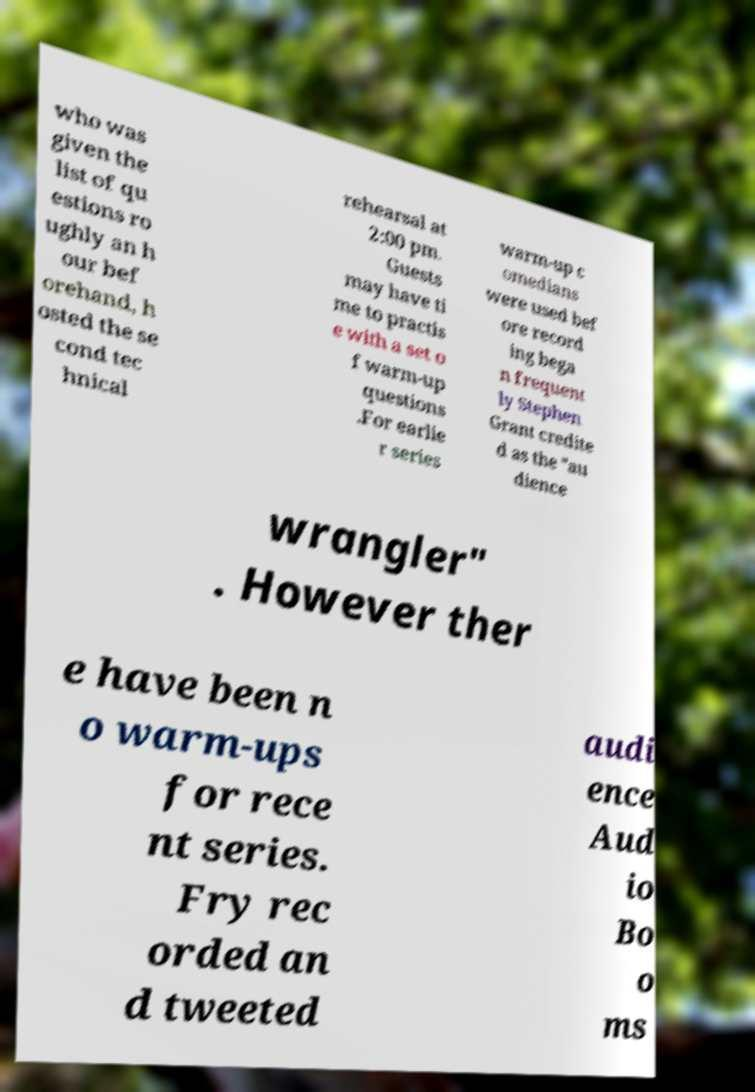Please identify and transcribe the text found in this image. who was given the list of qu estions ro ughly an h our bef orehand, h osted the se cond tec hnical rehearsal at 2:00 pm. Guests may have ti me to practis e with a set o f warm-up questions .For earlie r series warm-up c omedians were used bef ore record ing bega n frequent ly Stephen Grant credite d as the "au dience wrangler" . However ther e have been n o warm-ups for rece nt series. Fry rec orded an d tweeted audi ence Aud io Bo o ms 